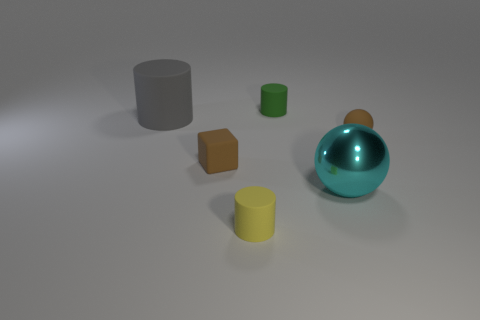Add 3 big objects. How many objects exist? 9 Subtract all spheres. How many objects are left? 4 Subtract 1 brown blocks. How many objects are left? 5 Subtract all large shiny balls. Subtract all tiny green cylinders. How many objects are left? 4 Add 5 tiny brown rubber blocks. How many tiny brown rubber blocks are left? 6 Add 5 big gray objects. How many big gray objects exist? 6 